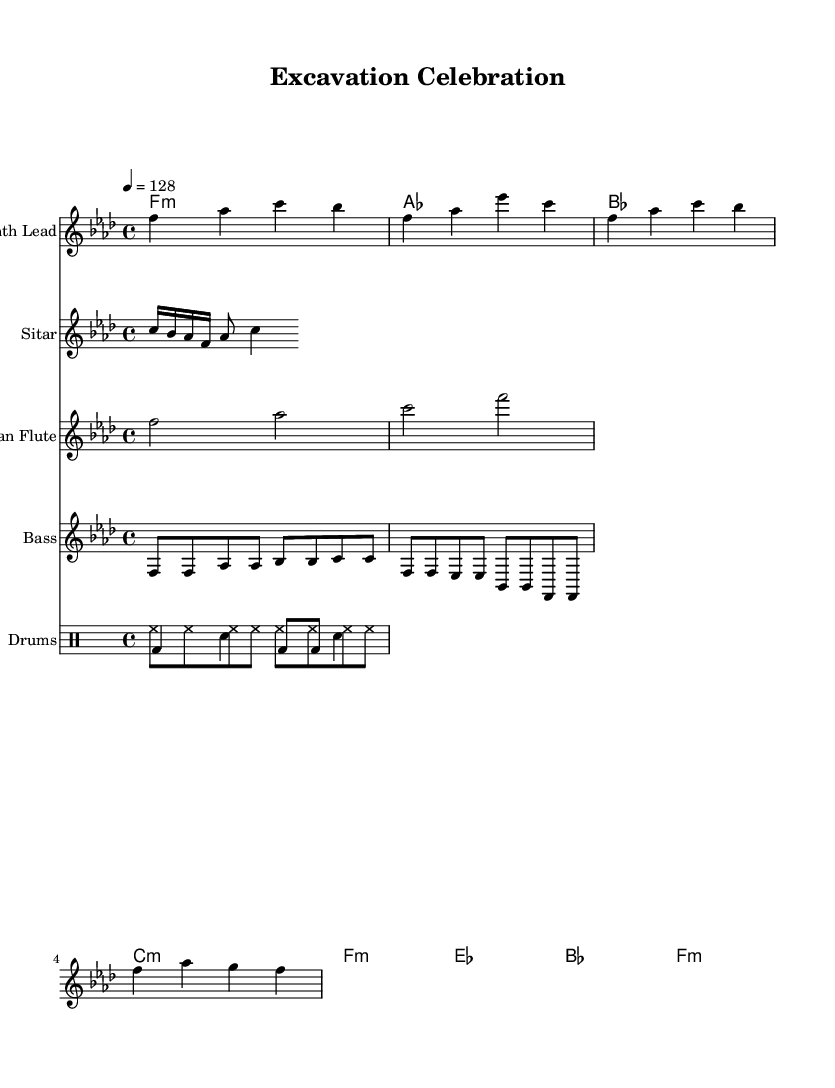What is the key signature of this music? The key signature is F minor, which has four flats (B♭, E♭, A♭, and D♭). This can be read from the beginning of the music sheet, indicated after the clefs.
Answer: F minor What is the time signature of this music? The time signature is 4/4, indicating that there are four beats in each measure and the quarter note gets one beat. This is shown at the beginning of the sheet music.
Answer: 4/4 What is the tempo marking of this piece? The tempo is marked as "4 = 128", which means there are 128 beats per minute when counting quarter notes. This is specified in the initial sections of the score.
Answer: 128 Which instruments are featured in this composition? The instruments include Synth Lead, Sitar, Pan Flute, Bass, and Drums. This information is found in the instrument names listed in the staff headers.
Answer: Synth Lead, Sitar, Pan Flute, Bass, Drums How many measures are in the Synth Lead part? The Synth Lead part contains four measures. This can be determined by counting the number of bar lines present in the staff for Synth Lead.
Answer: 4 What type of rhythmic patterns are used for the drums? The drumming features both Hi-hat and Bass Drum patterns, with distinct rhythms indicated in the drum sections. Specifically, one part has consistent hi-hat eighth notes, while the other part combines bass drum and snare.
Answer: Hi-hat and Bass Drum patterns How does the use of traditional instruments reflect the electronic dance music genre? Traditional instruments, like the Sitar and Pan Flute, are sampled and integrated into the electronic framework, creating a fusion that enriches the electronic vibe while maintaining cultural elements. This synthesis is characteristic of the genre's global influence.
Answer: Fusion of traditional and electronic elements 